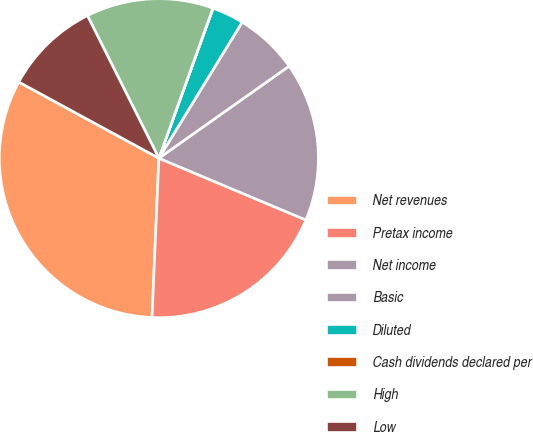Convert chart to OTSL. <chart><loc_0><loc_0><loc_500><loc_500><pie_chart><fcel>Net revenues<fcel>Pretax income<fcel>Net income<fcel>Basic<fcel>Diluted<fcel>Cash dividends declared per<fcel>High<fcel>Low<nl><fcel>32.24%<fcel>19.35%<fcel>16.13%<fcel>6.46%<fcel>3.23%<fcel>0.01%<fcel>12.9%<fcel>9.68%<nl></chart> 